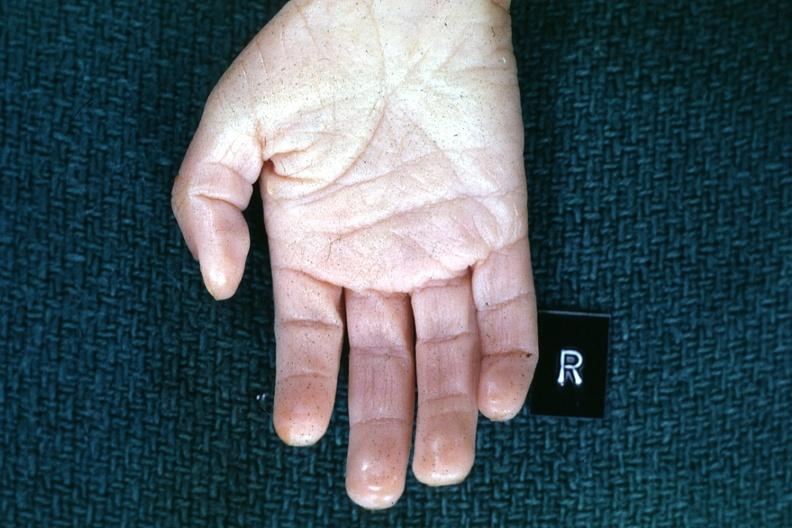s normal palmar creases present?
Answer the question using a single word or phrase. Yes 